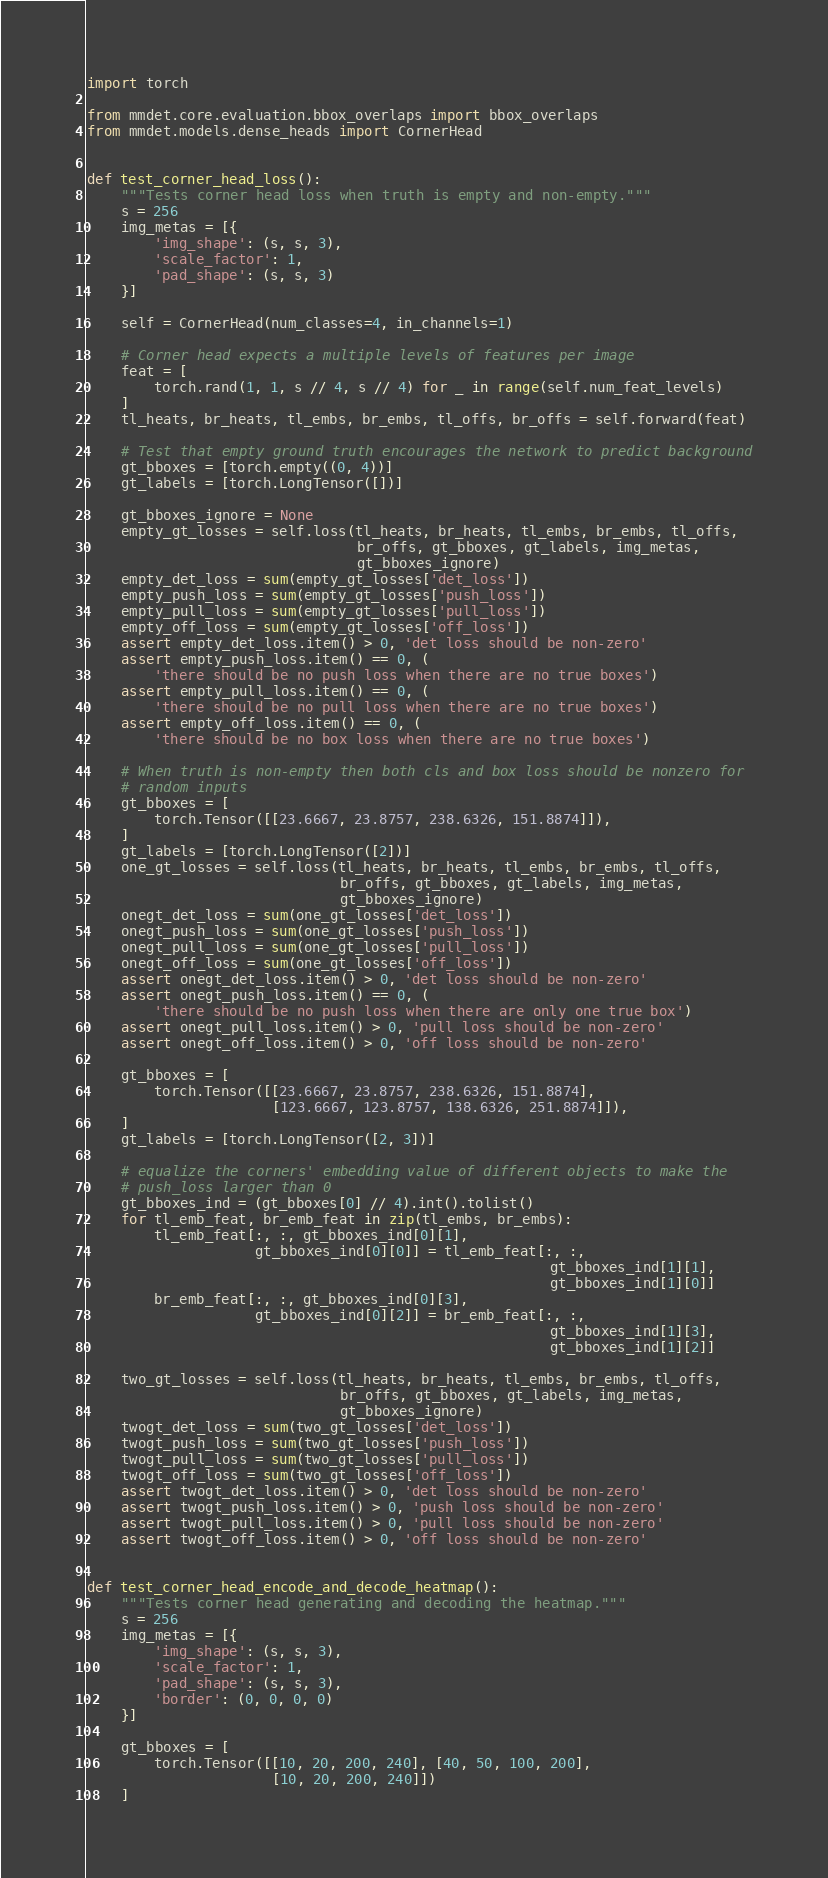<code> <loc_0><loc_0><loc_500><loc_500><_Python_>import torch

from mmdet.core.evaluation.bbox_overlaps import bbox_overlaps
from mmdet.models.dense_heads import CornerHead


def test_corner_head_loss():
    """Tests corner head loss when truth is empty and non-empty."""
    s = 256
    img_metas = [{
        'img_shape': (s, s, 3),
        'scale_factor': 1,
        'pad_shape': (s, s, 3)
    }]

    self = CornerHead(num_classes=4, in_channels=1)

    # Corner head expects a multiple levels of features per image
    feat = [
        torch.rand(1, 1, s // 4, s // 4) for _ in range(self.num_feat_levels)
    ]
    tl_heats, br_heats, tl_embs, br_embs, tl_offs, br_offs = self.forward(feat)

    # Test that empty ground truth encourages the network to predict background
    gt_bboxes = [torch.empty((0, 4))]
    gt_labels = [torch.LongTensor([])]

    gt_bboxes_ignore = None
    empty_gt_losses = self.loss(tl_heats, br_heats, tl_embs, br_embs, tl_offs,
                                br_offs, gt_bboxes, gt_labels, img_metas,
                                gt_bboxes_ignore)
    empty_det_loss = sum(empty_gt_losses['det_loss'])
    empty_push_loss = sum(empty_gt_losses['push_loss'])
    empty_pull_loss = sum(empty_gt_losses['pull_loss'])
    empty_off_loss = sum(empty_gt_losses['off_loss'])
    assert empty_det_loss.item() > 0, 'det loss should be non-zero'
    assert empty_push_loss.item() == 0, (
        'there should be no push loss when there are no true boxes')
    assert empty_pull_loss.item() == 0, (
        'there should be no pull loss when there are no true boxes')
    assert empty_off_loss.item() == 0, (
        'there should be no box loss when there are no true boxes')

    # When truth is non-empty then both cls and box loss should be nonzero for
    # random inputs
    gt_bboxes = [
        torch.Tensor([[23.6667, 23.8757, 238.6326, 151.8874]]),
    ]
    gt_labels = [torch.LongTensor([2])]
    one_gt_losses = self.loss(tl_heats, br_heats, tl_embs, br_embs, tl_offs,
                              br_offs, gt_bboxes, gt_labels, img_metas,
                              gt_bboxes_ignore)
    onegt_det_loss = sum(one_gt_losses['det_loss'])
    onegt_push_loss = sum(one_gt_losses['push_loss'])
    onegt_pull_loss = sum(one_gt_losses['pull_loss'])
    onegt_off_loss = sum(one_gt_losses['off_loss'])
    assert onegt_det_loss.item() > 0, 'det loss should be non-zero'
    assert onegt_push_loss.item() == 0, (
        'there should be no push loss when there are only one true box')
    assert onegt_pull_loss.item() > 0, 'pull loss should be non-zero'
    assert onegt_off_loss.item() > 0, 'off loss should be non-zero'

    gt_bboxes = [
        torch.Tensor([[23.6667, 23.8757, 238.6326, 151.8874],
                      [123.6667, 123.8757, 138.6326, 251.8874]]),
    ]
    gt_labels = [torch.LongTensor([2, 3])]

    # equalize the corners' embedding value of different objects to make the
    # push_loss larger than 0
    gt_bboxes_ind = (gt_bboxes[0] // 4).int().tolist()
    for tl_emb_feat, br_emb_feat in zip(tl_embs, br_embs):
        tl_emb_feat[:, :, gt_bboxes_ind[0][1],
                    gt_bboxes_ind[0][0]] = tl_emb_feat[:, :,
                                                       gt_bboxes_ind[1][1],
                                                       gt_bboxes_ind[1][0]]
        br_emb_feat[:, :, gt_bboxes_ind[0][3],
                    gt_bboxes_ind[0][2]] = br_emb_feat[:, :,
                                                       gt_bboxes_ind[1][3],
                                                       gt_bboxes_ind[1][2]]

    two_gt_losses = self.loss(tl_heats, br_heats, tl_embs, br_embs, tl_offs,
                              br_offs, gt_bboxes, gt_labels, img_metas,
                              gt_bboxes_ignore)
    twogt_det_loss = sum(two_gt_losses['det_loss'])
    twogt_push_loss = sum(two_gt_losses['push_loss'])
    twogt_pull_loss = sum(two_gt_losses['pull_loss'])
    twogt_off_loss = sum(two_gt_losses['off_loss'])
    assert twogt_det_loss.item() > 0, 'det loss should be non-zero'
    assert twogt_push_loss.item() > 0, 'push loss should be non-zero'
    assert twogt_pull_loss.item() > 0, 'pull loss should be non-zero'
    assert twogt_off_loss.item() > 0, 'off loss should be non-zero'


def test_corner_head_encode_and_decode_heatmap():
    """Tests corner head generating and decoding the heatmap."""
    s = 256
    img_metas = [{
        'img_shape': (s, s, 3),
        'scale_factor': 1,
        'pad_shape': (s, s, 3),
        'border': (0, 0, 0, 0)
    }]

    gt_bboxes = [
        torch.Tensor([[10, 20, 200, 240], [40, 50, 100, 200],
                      [10, 20, 200, 240]])
    ]</code> 